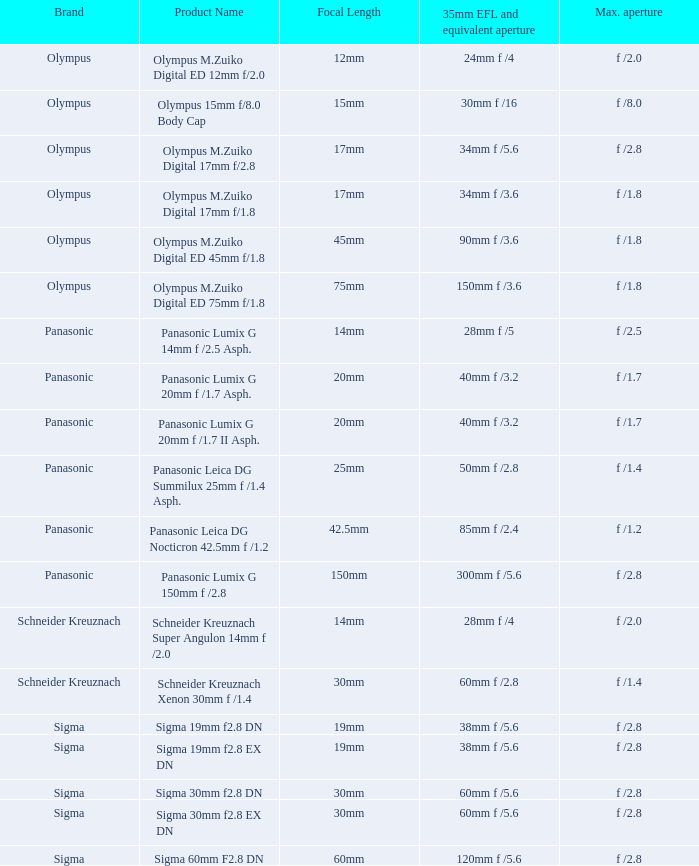8 and a 30mm focal distance? Sigma. 